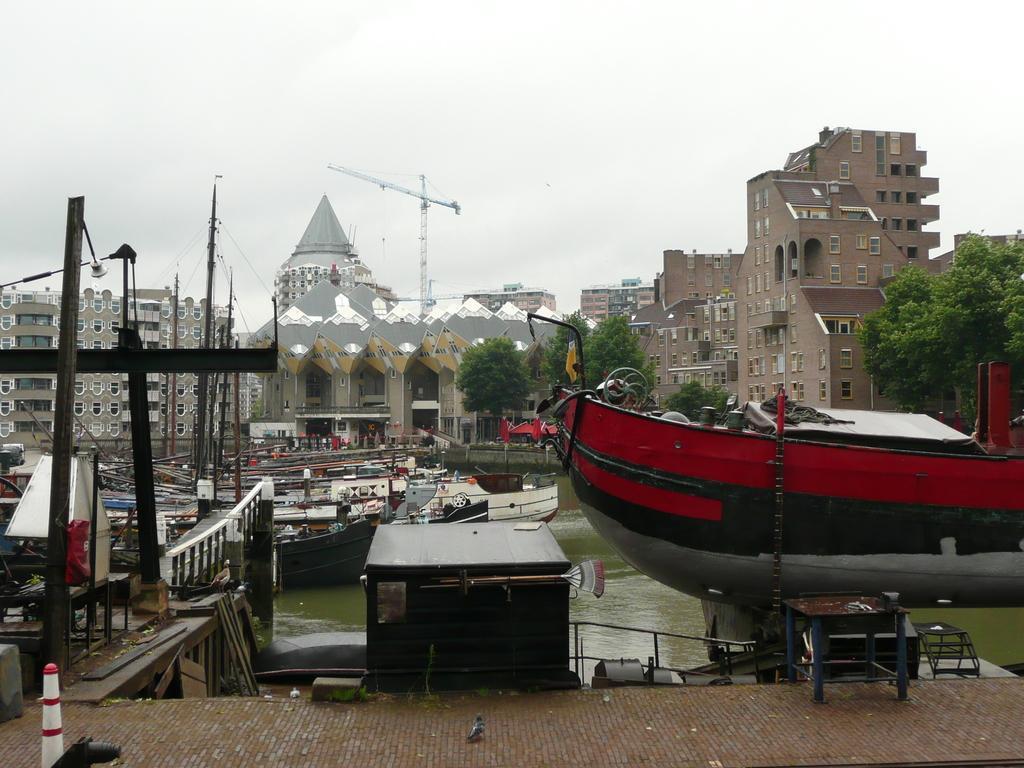Please provide a concise description of this image. In this picture we can see boats on the water, fences, platform, table, trees, crane, buildings with windows, some objects and in the background we can see the sky. 